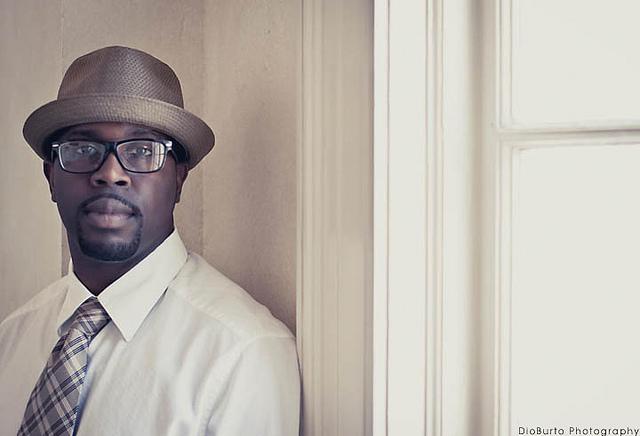What is on the man's head?
Short answer required. Hat. Does the man have 20/20 vision?
Write a very short answer. No. What color are his glasses?
Short answer required. Black. What is the pattern on his tie?
Give a very brief answer. Plaid. 